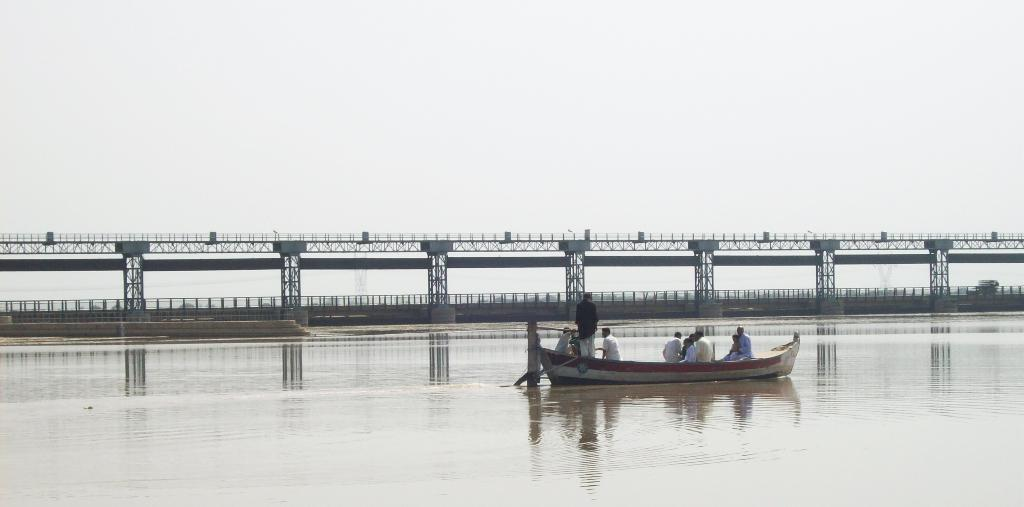What is the main subject of the image? The main subject of the image is persons in a boat. Where is the boat located in the image? The boat is sailing on a river in the center of the image. What can be seen in the background of the image? There is a bridge, water, and the sky visible in the background of the image. What type of brush is being used by the persons in the boat to paint the stage? There is no stage, brush, or painting activity present in the image. The persons in the boat are simply sailing on a river. 